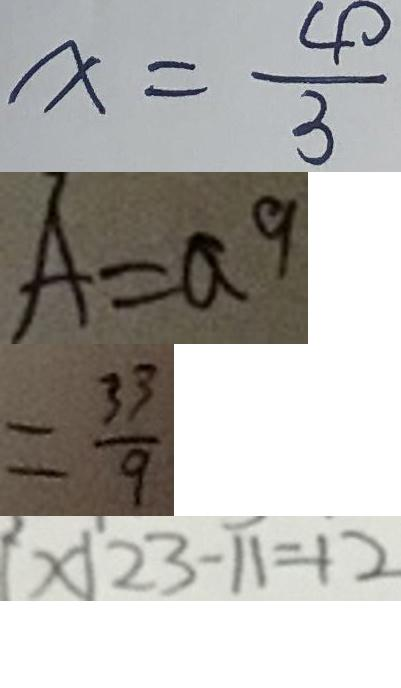<formula> <loc_0><loc_0><loc_500><loc_500>x = \frac { 4 0 } { 3 } 
 A = a 9 
 = \frac { 3 3 } { 9 } 
 [ x \vert 2 3 - 1 1 = 1 2</formula> 